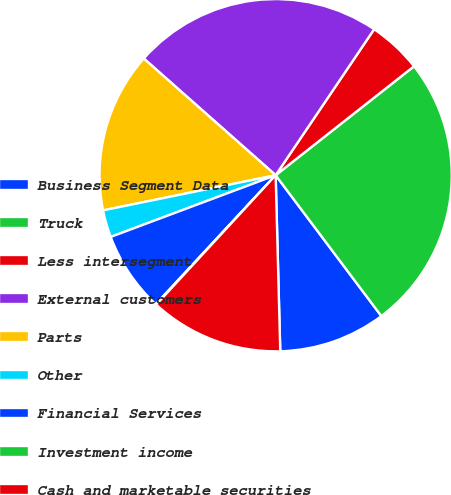Convert chart. <chart><loc_0><loc_0><loc_500><loc_500><pie_chart><fcel>Business Segment Data<fcel>Truck<fcel>Less intersegment<fcel>External customers<fcel>Parts<fcel>Other<fcel>Financial Services<fcel>Investment income<fcel>Cash and marketable securities<nl><fcel>9.83%<fcel>25.37%<fcel>4.94%<fcel>22.92%<fcel>14.73%<fcel>2.5%<fcel>7.39%<fcel>0.05%<fcel>12.28%<nl></chart> 